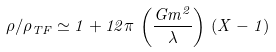<formula> <loc_0><loc_0><loc_500><loc_500>\rho / \rho _ { T F } \simeq 1 + 1 2 \pi \, \left ( \frac { G m ^ { 2 } } { \lambda } \right ) \, ( X - 1 )</formula> 